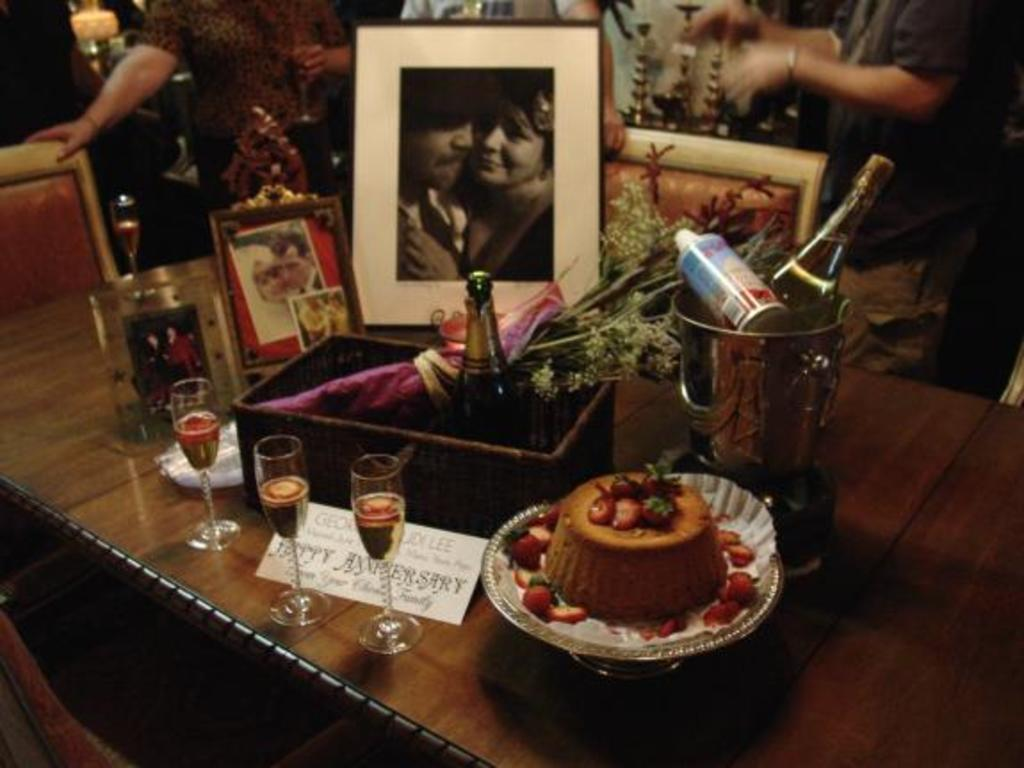What is the main food item visible in the image? There is a cake on a plate in the image. What type of container is present in the image? There is a glass in the image. What other beverage container can be seen in the image? There is a bottle in the image. What type of container is used for holding liquids in the image? There is a jug in the image. What decorative item is present in the image? There is a frame in the image. Are there any people visible in the image? Yes, there are people standing in the background of the image. What type of furniture is present in the image? There is a chair in the image. What type of badge is pinned to the cake in the image? There is no badge present on the cake in the image. What type of glass is used to cover the cake in the image? There is no glass covering the cake in the image; it is on a plate. 